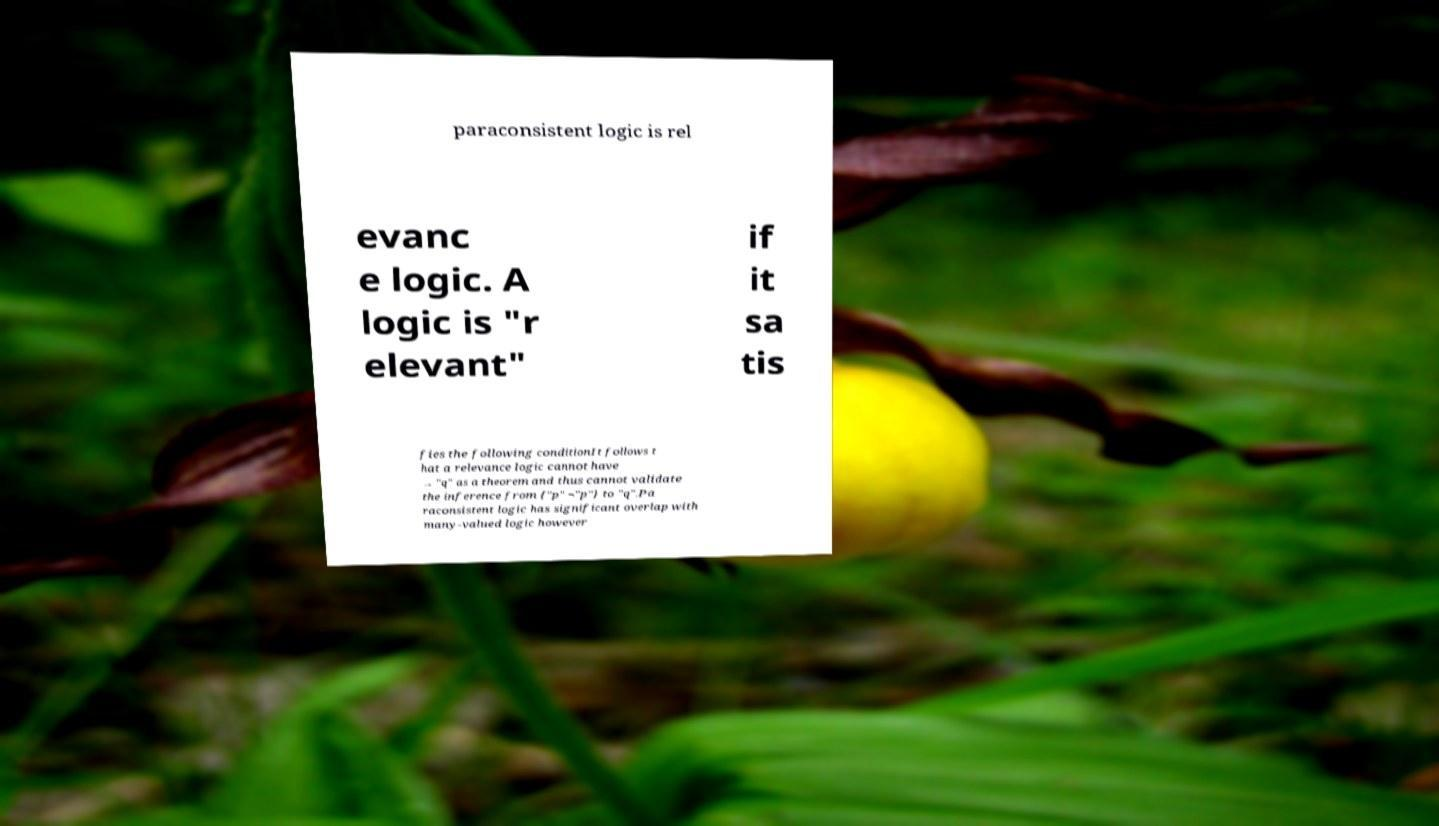For documentation purposes, I need the text within this image transcribed. Could you provide that? paraconsistent logic is rel evanc e logic. A logic is "r elevant" if it sa tis fies the following conditionIt follows t hat a relevance logic cannot have → "q" as a theorem and thus cannot validate the inference from {"p" ¬"p"} to "q".Pa raconsistent logic has significant overlap with many-valued logic however 